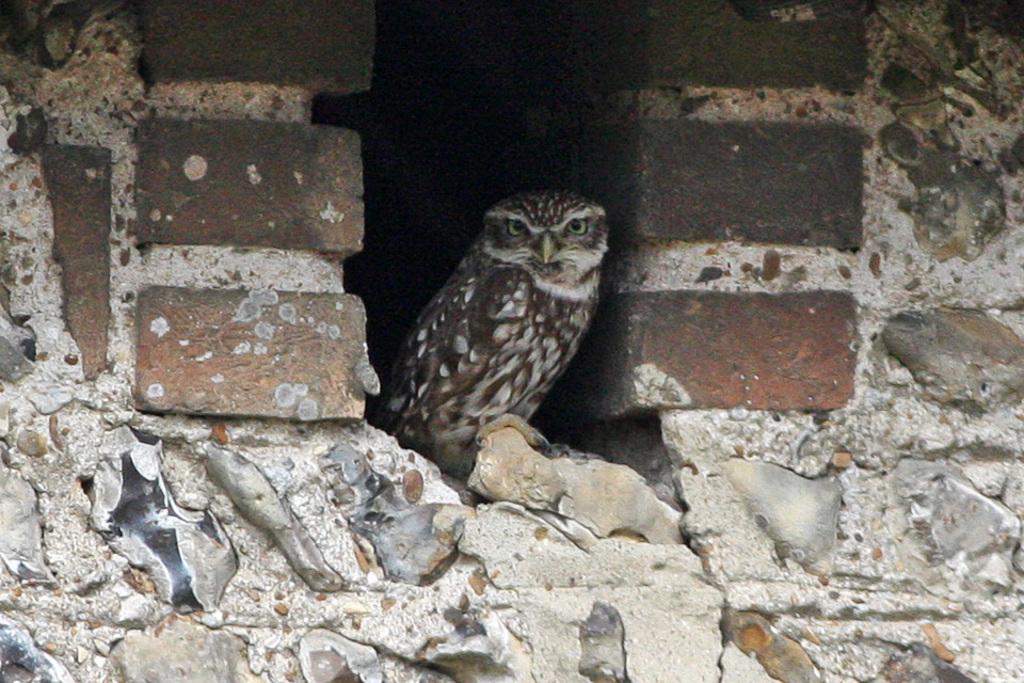Can you describe this image briefly? In this image I can see the bird and the bird is in brown and cream color. Background the wall is in brown and cream color. 